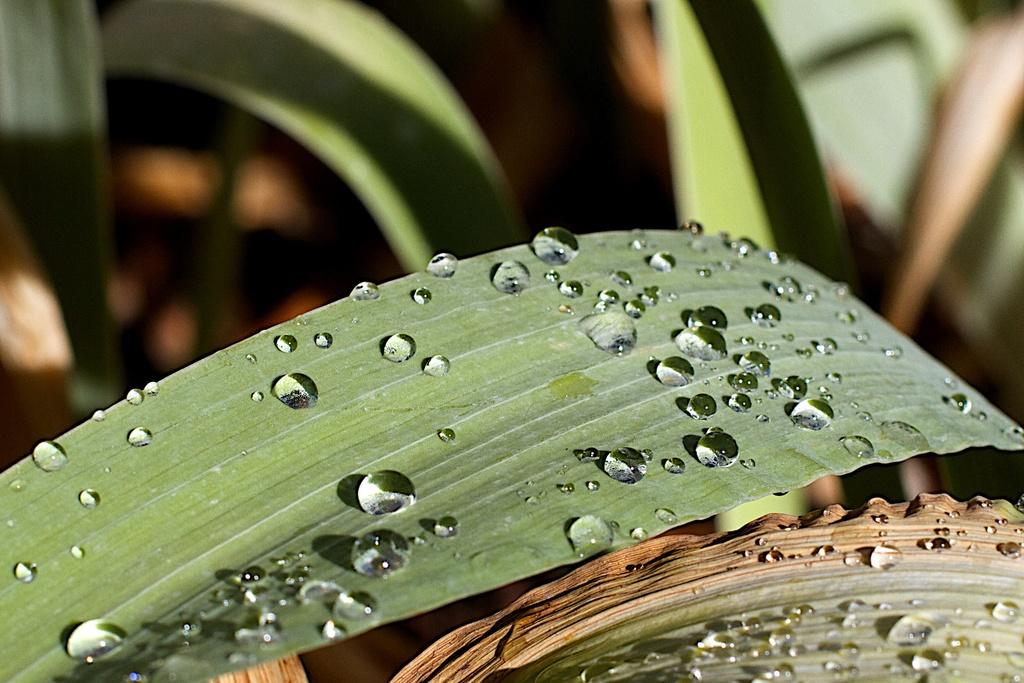What is present in the image? There is a plant in the image. Can you describe the plant in more detail? There is a leaf on the plant. Are there any additional features on the leaf? Yes, there are water droplets on the leaf. What type of line is being used to measure the height of the plant in the image? There is no line or measurement activity depicted in the image; it only shows a plant with a leaf and water droplets. 